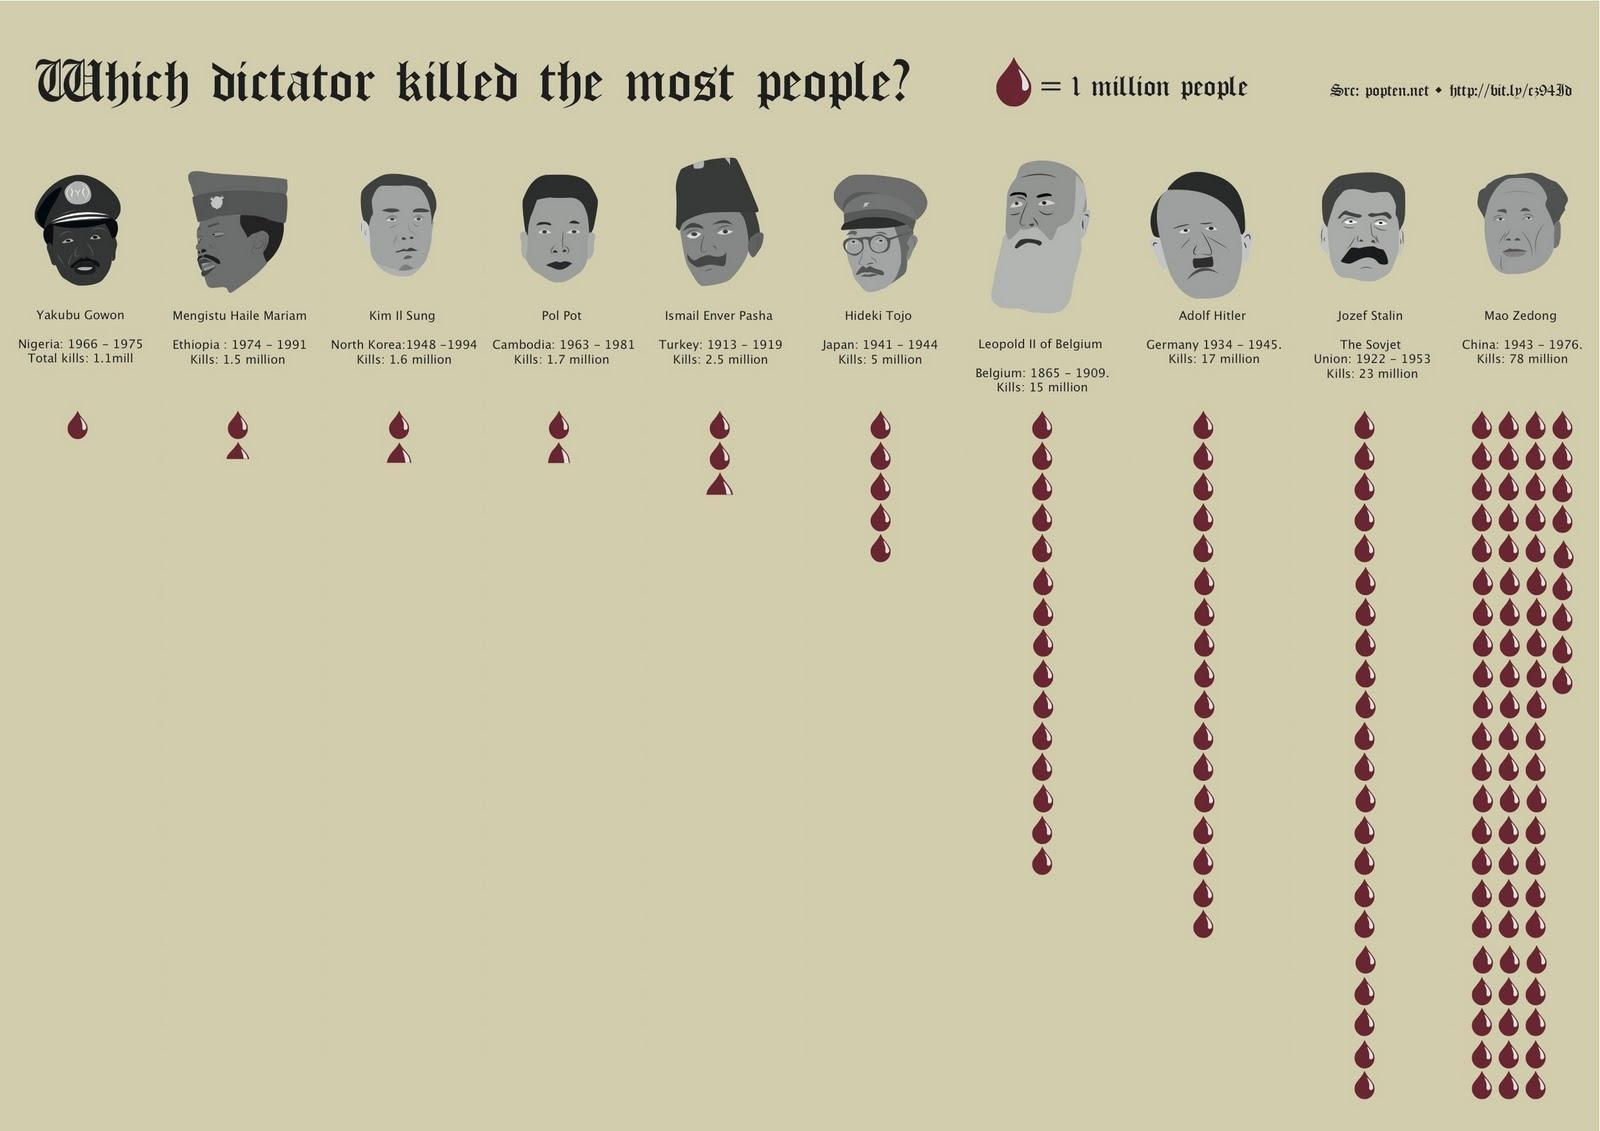which country had the second largest killing
Answer the question with a short phrase. the soviet union who killed 2.5 million Ismail Enver Pasha how many did Adolf Hitler kill? 17 million how many dictators have worn caps 4 what is the colour of blood droplets, red or green red Which country was Hideki Tojo from Japan Which year range did Pol Pot belong to 1963 - 1981 In how many years did Mao Zedong kill 78 million 33 